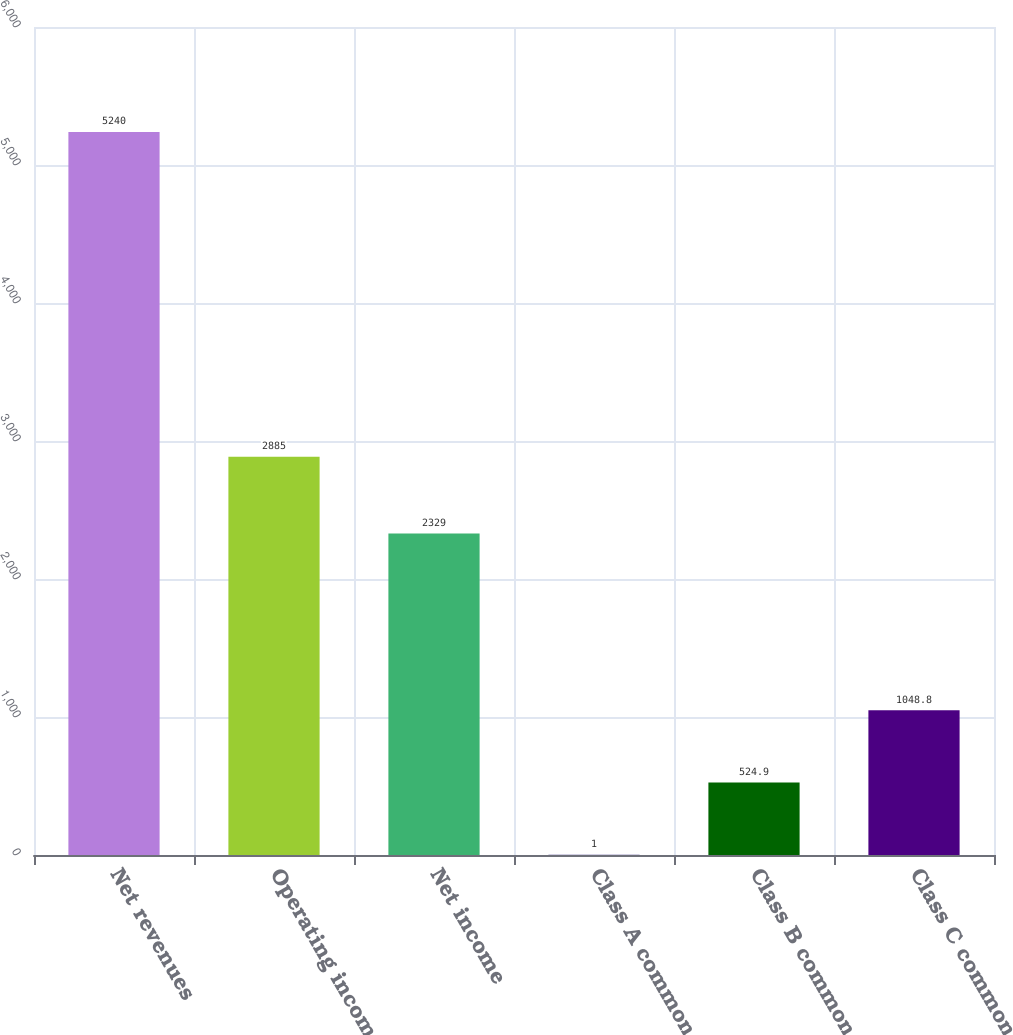Convert chart. <chart><loc_0><loc_0><loc_500><loc_500><bar_chart><fcel>Net revenues<fcel>Operating income<fcel>Net income<fcel>Class A common stock<fcel>Class B common stock<fcel>Class C common stock<nl><fcel>5240<fcel>2885<fcel>2329<fcel>1<fcel>524.9<fcel>1048.8<nl></chart> 